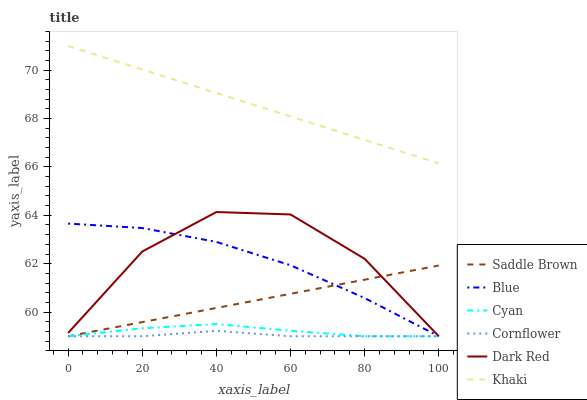Does Cornflower have the minimum area under the curve?
Answer yes or no. Yes. Does Khaki have the maximum area under the curve?
Answer yes or no. Yes. Does Khaki have the minimum area under the curve?
Answer yes or no. No. Does Cornflower have the maximum area under the curve?
Answer yes or no. No. Is Khaki the smoothest?
Answer yes or no. Yes. Is Dark Red the roughest?
Answer yes or no. Yes. Is Cornflower the smoothest?
Answer yes or no. No. Is Cornflower the roughest?
Answer yes or no. No. Does Blue have the lowest value?
Answer yes or no. Yes. Does Khaki have the lowest value?
Answer yes or no. No. Does Khaki have the highest value?
Answer yes or no. Yes. Does Cornflower have the highest value?
Answer yes or no. No. Is Dark Red less than Khaki?
Answer yes or no. Yes. Is Khaki greater than Saddle Brown?
Answer yes or no. Yes. Does Saddle Brown intersect Cornflower?
Answer yes or no. Yes. Is Saddle Brown less than Cornflower?
Answer yes or no. No. Is Saddle Brown greater than Cornflower?
Answer yes or no. No. Does Dark Red intersect Khaki?
Answer yes or no. No. 